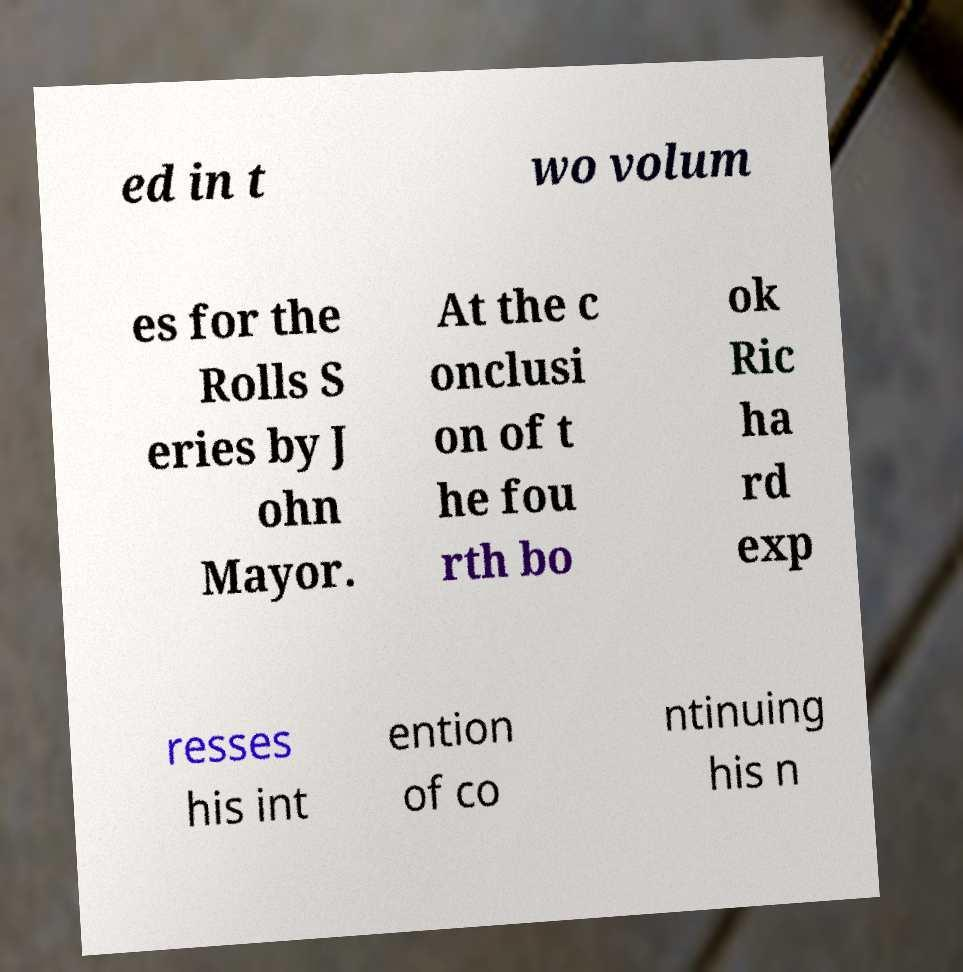For documentation purposes, I need the text within this image transcribed. Could you provide that? ed in t wo volum es for the Rolls S eries by J ohn Mayor. At the c onclusi on of t he fou rth bo ok Ric ha rd exp resses his int ention of co ntinuing his n 